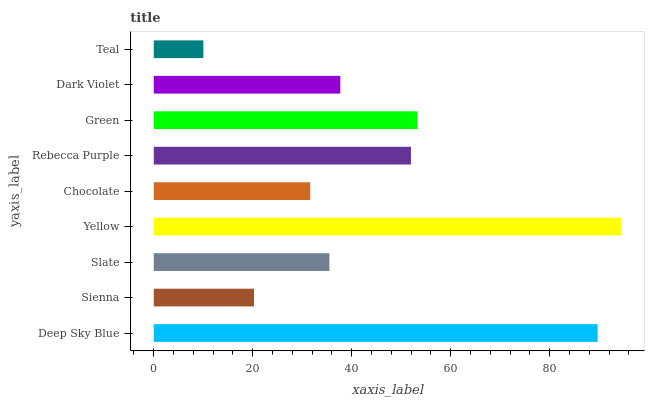Is Teal the minimum?
Answer yes or no. Yes. Is Yellow the maximum?
Answer yes or no. Yes. Is Sienna the minimum?
Answer yes or no. No. Is Sienna the maximum?
Answer yes or no. No. Is Deep Sky Blue greater than Sienna?
Answer yes or no. Yes. Is Sienna less than Deep Sky Blue?
Answer yes or no. Yes. Is Sienna greater than Deep Sky Blue?
Answer yes or no. No. Is Deep Sky Blue less than Sienna?
Answer yes or no. No. Is Dark Violet the high median?
Answer yes or no. Yes. Is Dark Violet the low median?
Answer yes or no. Yes. Is Teal the high median?
Answer yes or no. No. Is Teal the low median?
Answer yes or no. No. 